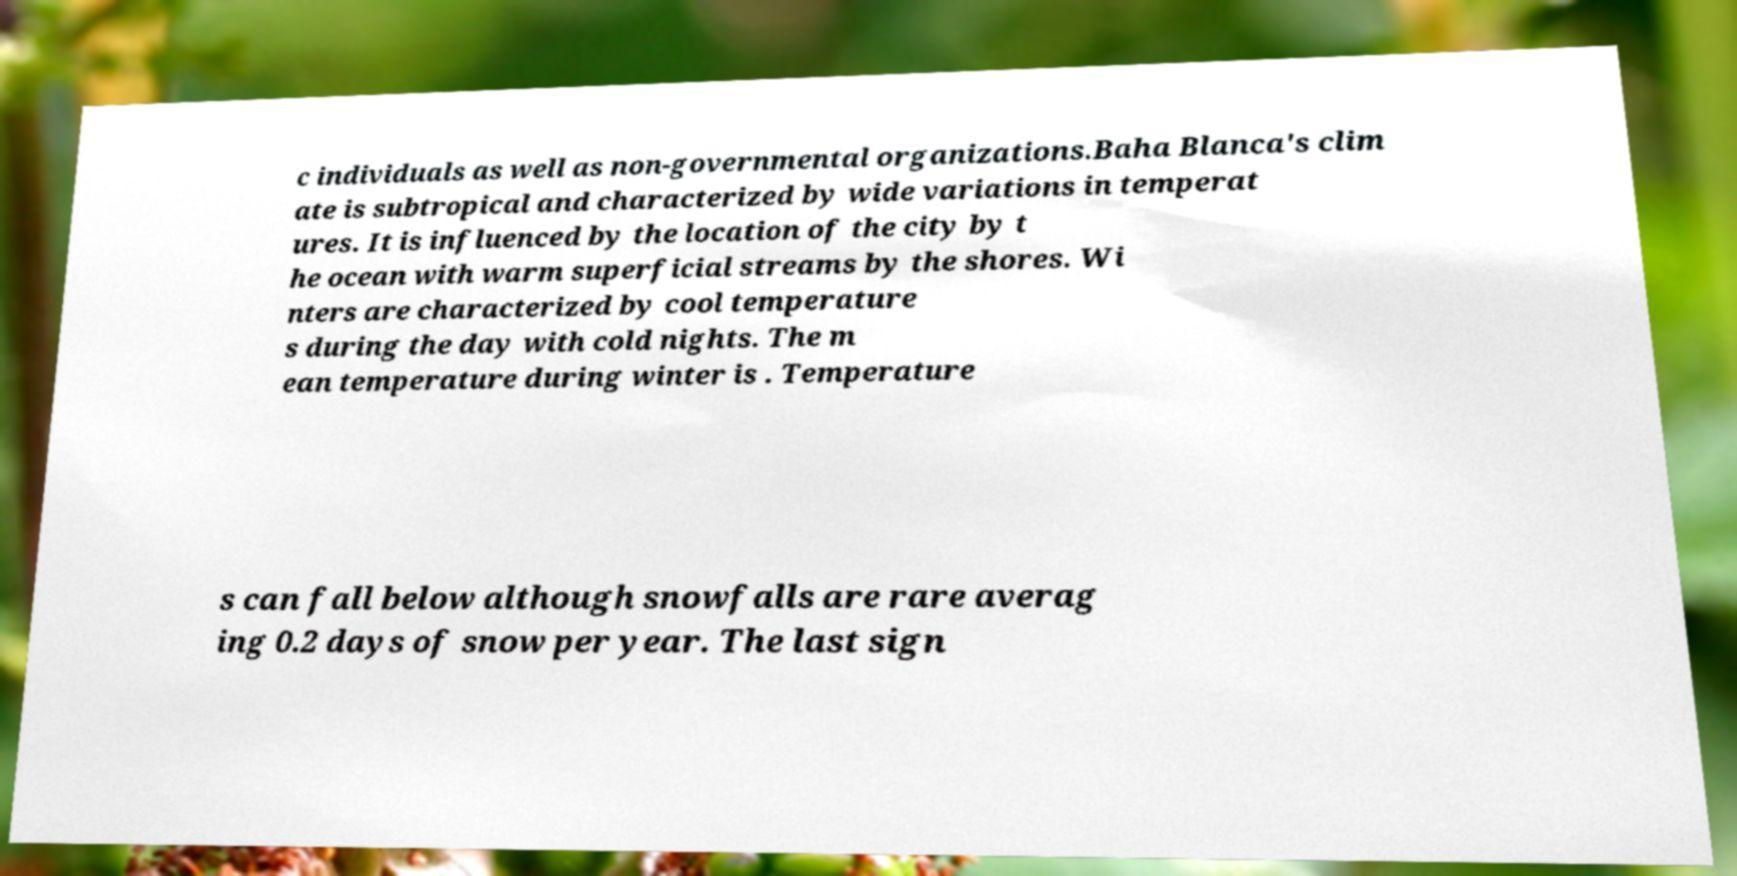There's text embedded in this image that I need extracted. Can you transcribe it verbatim? c individuals as well as non-governmental organizations.Baha Blanca's clim ate is subtropical and characterized by wide variations in temperat ures. It is influenced by the location of the city by t he ocean with warm superficial streams by the shores. Wi nters are characterized by cool temperature s during the day with cold nights. The m ean temperature during winter is . Temperature s can fall below although snowfalls are rare averag ing 0.2 days of snow per year. The last sign 